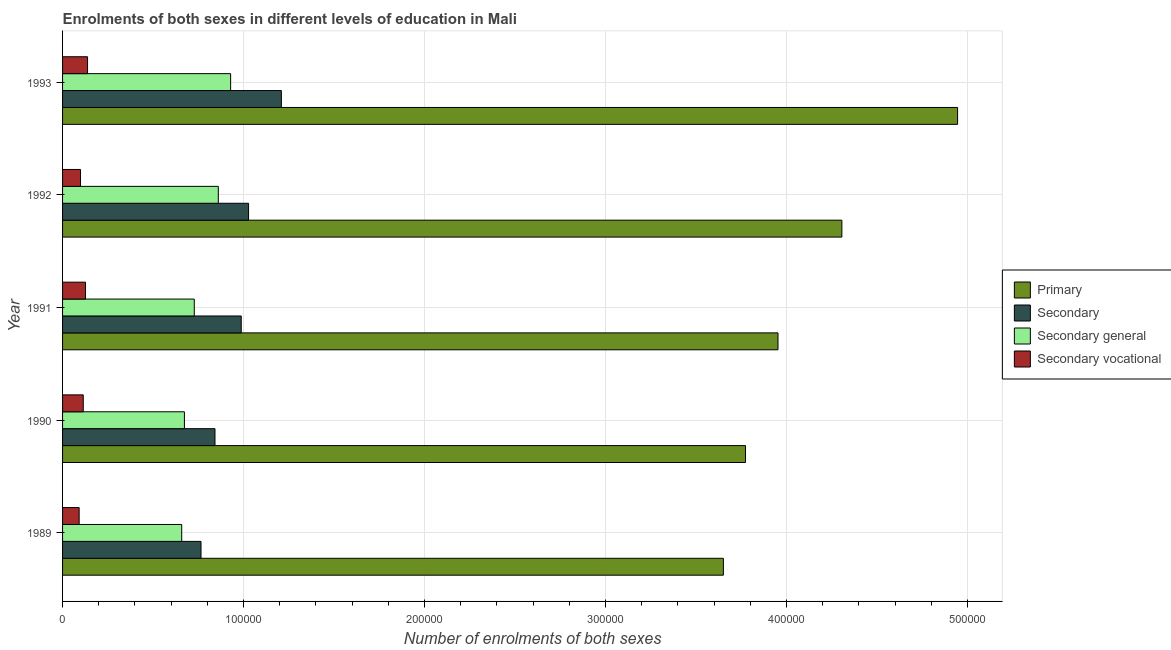How many different coloured bars are there?
Offer a terse response. 4. How many groups of bars are there?
Provide a short and direct response. 5. Are the number of bars per tick equal to the number of legend labels?
Your answer should be compact. Yes. How many bars are there on the 4th tick from the top?
Offer a terse response. 4. How many bars are there on the 4th tick from the bottom?
Make the answer very short. 4. In how many cases, is the number of bars for a given year not equal to the number of legend labels?
Provide a short and direct response. 0. What is the number of enrolments in primary education in 1992?
Your answer should be very brief. 4.31e+05. Across all years, what is the maximum number of enrolments in secondary general education?
Your response must be concise. 9.29e+04. Across all years, what is the minimum number of enrolments in secondary vocational education?
Your answer should be compact. 9164. In which year was the number of enrolments in primary education minimum?
Your answer should be very brief. 1989. What is the total number of enrolments in secondary vocational education in the graph?
Your answer should be very brief. 5.70e+04. What is the difference between the number of enrolments in secondary vocational education in 1989 and that in 1992?
Your answer should be very brief. -751. What is the difference between the number of enrolments in primary education in 1991 and the number of enrolments in secondary vocational education in 1993?
Give a very brief answer. 3.82e+05. What is the average number of enrolments in secondary education per year?
Keep it short and to the point. 9.66e+04. In the year 1989, what is the difference between the number of enrolments in primary education and number of enrolments in secondary education?
Offer a very short reply. 2.89e+05. What is the ratio of the number of enrolments in secondary education in 1992 to that in 1993?
Your answer should be very brief. 0.85. What is the difference between the highest and the second highest number of enrolments in secondary general education?
Your response must be concise. 6801. What is the difference between the highest and the lowest number of enrolments in primary education?
Your answer should be compact. 1.29e+05. In how many years, is the number of enrolments in primary education greater than the average number of enrolments in primary education taken over all years?
Offer a very short reply. 2. Is it the case that in every year, the sum of the number of enrolments in secondary vocational education and number of enrolments in secondary general education is greater than the sum of number of enrolments in primary education and number of enrolments in secondary education?
Give a very brief answer. No. What does the 3rd bar from the top in 1989 represents?
Provide a succinct answer. Secondary. What does the 1st bar from the bottom in 1991 represents?
Ensure brevity in your answer.  Primary. Is it the case that in every year, the sum of the number of enrolments in primary education and number of enrolments in secondary education is greater than the number of enrolments in secondary general education?
Provide a short and direct response. Yes. How many bars are there?
Provide a short and direct response. 20. How many years are there in the graph?
Offer a very short reply. 5. Are the values on the major ticks of X-axis written in scientific E-notation?
Offer a terse response. No. Does the graph contain any zero values?
Your answer should be very brief. No. Does the graph contain grids?
Your answer should be very brief. Yes. Where does the legend appear in the graph?
Your answer should be compact. Center right. How many legend labels are there?
Give a very brief answer. 4. What is the title of the graph?
Provide a short and direct response. Enrolments of both sexes in different levels of education in Mali. Does "Overall level" appear as one of the legend labels in the graph?
Provide a short and direct response. No. What is the label or title of the X-axis?
Keep it short and to the point. Number of enrolments of both sexes. What is the label or title of the Y-axis?
Ensure brevity in your answer.  Year. What is the Number of enrolments of both sexes in Primary in 1989?
Provide a short and direct response. 3.65e+05. What is the Number of enrolments of both sexes in Secondary in 1989?
Give a very brief answer. 7.65e+04. What is the Number of enrolments of both sexes of Secondary general in 1989?
Give a very brief answer. 6.58e+04. What is the Number of enrolments of both sexes of Secondary vocational in 1989?
Ensure brevity in your answer.  9164. What is the Number of enrolments of both sexes of Primary in 1990?
Make the answer very short. 3.77e+05. What is the Number of enrolments of both sexes of Secondary in 1990?
Your answer should be very brief. 8.42e+04. What is the Number of enrolments of both sexes of Secondary general in 1990?
Provide a succinct answer. 6.73e+04. What is the Number of enrolments of both sexes in Secondary vocational in 1990?
Ensure brevity in your answer.  1.14e+04. What is the Number of enrolments of both sexes of Primary in 1991?
Offer a terse response. 3.95e+05. What is the Number of enrolments of both sexes in Secondary in 1991?
Provide a succinct answer. 9.87e+04. What is the Number of enrolments of both sexes of Secondary general in 1991?
Provide a short and direct response. 7.28e+04. What is the Number of enrolments of both sexes in Secondary vocational in 1991?
Offer a very short reply. 1.27e+04. What is the Number of enrolments of both sexes in Primary in 1992?
Give a very brief answer. 4.31e+05. What is the Number of enrolments of both sexes in Secondary in 1992?
Provide a short and direct response. 1.03e+05. What is the Number of enrolments of both sexes of Secondary general in 1992?
Your response must be concise. 8.61e+04. What is the Number of enrolments of both sexes in Secondary vocational in 1992?
Offer a terse response. 9915. What is the Number of enrolments of both sexes of Primary in 1993?
Give a very brief answer. 4.95e+05. What is the Number of enrolments of both sexes of Secondary in 1993?
Your answer should be very brief. 1.21e+05. What is the Number of enrolments of both sexes in Secondary general in 1993?
Offer a very short reply. 9.29e+04. What is the Number of enrolments of both sexes in Secondary vocational in 1993?
Your response must be concise. 1.38e+04. Across all years, what is the maximum Number of enrolments of both sexes of Primary?
Your response must be concise. 4.95e+05. Across all years, what is the maximum Number of enrolments of both sexes of Secondary?
Offer a very short reply. 1.21e+05. Across all years, what is the maximum Number of enrolments of both sexes of Secondary general?
Provide a short and direct response. 9.29e+04. Across all years, what is the maximum Number of enrolments of both sexes in Secondary vocational?
Make the answer very short. 1.38e+04. Across all years, what is the minimum Number of enrolments of both sexes in Primary?
Provide a succinct answer. 3.65e+05. Across all years, what is the minimum Number of enrolments of both sexes of Secondary?
Your answer should be very brief. 7.65e+04. Across all years, what is the minimum Number of enrolments of both sexes in Secondary general?
Provide a short and direct response. 6.58e+04. Across all years, what is the minimum Number of enrolments of both sexes in Secondary vocational?
Provide a succinct answer. 9164. What is the total Number of enrolments of both sexes in Primary in the graph?
Provide a short and direct response. 2.06e+06. What is the total Number of enrolments of both sexes of Secondary in the graph?
Make the answer very short. 4.83e+05. What is the total Number of enrolments of both sexes in Secondary general in the graph?
Provide a short and direct response. 3.85e+05. What is the total Number of enrolments of both sexes in Secondary vocational in the graph?
Keep it short and to the point. 5.70e+04. What is the difference between the Number of enrolments of both sexes in Primary in 1989 and that in 1990?
Ensure brevity in your answer.  -1.22e+04. What is the difference between the Number of enrolments of both sexes of Secondary in 1989 and that in 1990?
Provide a short and direct response. -7719. What is the difference between the Number of enrolments of both sexes of Secondary general in 1989 and that in 1990?
Ensure brevity in your answer.  -1505. What is the difference between the Number of enrolments of both sexes in Secondary vocational in 1989 and that in 1990?
Provide a short and direct response. -2268. What is the difference between the Number of enrolments of both sexes of Primary in 1989 and that in 1991?
Provide a succinct answer. -3.02e+04. What is the difference between the Number of enrolments of both sexes of Secondary in 1989 and that in 1991?
Keep it short and to the point. -2.22e+04. What is the difference between the Number of enrolments of both sexes of Secondary general in 1989 and that in 1991?
Offer a very short reply. -6956. What is the difference between the Number of enrolments of both sexes in Secondary vocational in 1989 and that in 1991?
Keep it short and to the point. -3508. What is the difference between the Number of enrolments of both sexes in Primary in 1989 and that in 1992?
Provide a succinct answer. -6.55e+04. What is the difference between the Number of enrolments of both sexes of Secondary in 1989 and that in 1992?
Provide a short and direct response. -2.63e+04. What is the difference between the Number of enrolments of both sexes in Secondary general in 1989 and that in 1992?
Provide a short and direct response. -2.02e+04. What is the difference between the Number of enrolments of both sexes in Secondary vocational in 1989 and that in 1992?
Your answer should be very brief. -751. What is the difference between the Number of enrolments of both sexes of Primary in 1989 and that in 1993?
Offer a very short reply. -1.29e+05. What is the difference between the Number of enrolments of both sexes of Secondary in 1989 and that in 1993?
Give a very brief answer. -4.44e+04. What is the difference between the Number of enrolments of both sexes of Secondary general in 1989 and that in 1993?
Make the answer very short. -2.70e+04. What is the difference between the Number of enrolments of both sexes in Secondary vocational in 1989 and that in 1993?
Your answer should be compact. -4643. What is the difference between the Number of enrolments of both sexes in Primary in 1990 and that in 1991?
Your answer should be very brief. -1.80e+04. What is the difference between the Number of enrolments of both sexes of Secondary in 1990 and that in 1991?
Provide a succinct answer. -1.45e+04. What is the difference between the Number of enrolments of both sexes of Secondary general in 1990 and that in 1991?
Offer a very short reply. -5451. What is the difference between the Number of enrolments of both sexes of Secondary vocational in 1990 and that in 1991?
Your response must be concise. -1240. What is the difference between the Number of enrolments of both sexes in Primary in 1990 and that in 1992?
Keep it short and to the point. -5.33e+04. What is the difference between the Number of enrolments of both sexes of Secondary in 1990 and that in 1992?
Offer a very short reply. -1.86e+04. What is the difference between the Number of enrolments of both sexes of Secondary general in 1990 and that in 1992?
Keep it short and to the point. -1.87e+04. What is the difference between the Number of enrolments of both sexes of Secondary vocational in 1990 and that in 1992?
Ensure brevity in your answer.  1517. What is the difference between the Number of enrolments of both sexes in Primary in 1990 and that in 1993?
Make the answer very short. -1.17e+05. What is the difference between the Number of enrolments of both sexes of Secondary in 1990 and that in 1993?
Ensure brevity in your answer.  -3.67e+04. What is the difference between the Number of enrolments of both sexes of Secondary general in 1990 and that in 1993?
Your answer should be compact. -2.55e+04. What is the difference between the Number of enrolments of both sexes in Secondary vocational in 1990 and that in 1993?
Your answer should be very brief. -2375. What is the difference between the Number of enrolments of both sexes of Primary in 1991 and that in 1992?
Your answer should be compact. -3.53e+04. What is the difference between the Number of enrolments of both sexes in Secondary in 1991 and that in 1992?
Provide a short and direct response. -4044. What is the difference between the Number of enrolments of both sexes in Secondary general in 1991 and that in 1992?
Give a very brief answer. -1.33e+04. What is the difference between the Number of enrolments of both sexes of Secondary vocational in 1991 and that in 1992?
Your response must be concise. 2757. What is the difference between the Number of enrolments of both sexes in Primary in 1991 and that in 1993?
Keep it short and to the point. -9.92e+04. What is the difference between the Number of enrolments of both sexes in Secondary in 1991 and that in 1993?
Provide a short and direct response. -2.22e+04. What is the difference between the Number of enrolments of both sexes of Secondary general in 1991 and that in 1993?
Your response must be concise. -2.01e+04. What is the difference between the Number of enrolments of both sexes of Secondary vocational in 1991 and that in 1993?
Provide a succinct answer. -1135. What is the difference between the Number of enrolments of both sexes in Primary in 1992 and that in 1993?
Offer a very short reply. -6.39e+04. What is the difference between the Number of enrolments of both sexes in Secondary in 1992 and that in 1993?
Your answer should be compact. -1.81e+04. What is the difference between the Number of enrolments of both sexes in Secondary general in 1992 and that in 1993?
Keep it short and to the point. -6801. What is the difference between the Number of enrolments of both sexes of Secondary vocational in 1992 and that in 1993?
Your response must be concise. -3892. What is the difference between the Number of enrolments of both sexes in Primary in 1989 and the Number of enrolments of both sexes in Secondary in 1990?
Your answer should be compact. 2.81e+05. What is the difference between the Number of enrolments of both sexes in Primary in 1989 and the Number of enrolments of both sexes in Secondary general in 1990?
Provide a short and direct response. 2.98e+05. What is the difference between the Number of enrolments of both sexes in Primary in 1989 and the Number of enrolments of both sexes in Secondary vocational in 1990?
Give a very brief answer. 3.54e+05. What is the difference between the Number of enrolments of both sexes of Secondary in 1989 and the Number of enrolments of both sexes of Secondary general in 1990?
Provide a succinct answer. 9164. What is the difference between the Number of enrolments of both sexes in Secondary in 1989 and the Number of enrolments of both sexes in Secondary vocational in 1990?
Give a very brief answer. 6.51e+04. What is the difference between the Number of enrolments of both sexes in Secondary general in 1989 and the Number of enrolments of both sexes in Secondary vocational in 1990?
Your response must be concise. 5.44e+04. What is the difference between the Number of enrolments of both sexes in Primary in 1989 and the Number of enrolments of both sexes in Secondary in 1991?
Offer a terse response. 2.66e+05. What is the difference between the Number of enrolments of both sexes of Primary in 1989 and the Number of enrolments of both sexes of Secondary general in 1991?
Your response must be concise. 2.92e+05. What is the difference between the Number of enrolments of both sexes in Primary in 1989 and the Number of enrolments of both sexes in Secondary vocational in 1991?
Ensure brevity in your answer.  3.52e+05. What is the difference between the Number of enrolments of both sexes of Secondary in 1989 and the Number of enrolments of both sexes of Secondary general in 1991?
Make the answer very short. 3713. What is the difference between the Number of enrolments of both sexes in Secondary in 1989 and the Number of enrolments of both sexes in Secondary vocational in 1991?
Your answer should be very brief. 6.38e+04. What is the difference between the Number of enrolments of both sexes of Secondary general in 1989 and the Number of enrolments of both sexes of Secondary vocational in 1991?
Ensure brevity in your answer.  5.32e+04. What is the difference between the Number of enrolments of both sexes of Primary in 1989 and the Number of enrolments of both sexes of Secondary in 1992?
Keep it short and to the point. 2.62e+05. What is the difference between the Number of enrolments of both sexes of Primary in 1989 and the Number of enrolments of both sexes of Secondary general in 1992?
Your answer should be very brief. 2.79e+05. What is the difference between the Number of enrolments of both sexes of Primary in 1989 and the Number of enrolments of both sexes of Secondary vocational in 1992?
Give a very brief answer. 3.55e+05. What is the difference between the Number of enrolments of both sexes of Secondary in 1989 and the Number of enrolments of both sexes of Secondary general in 1992?
Your response must be concise. -9564. What is the difference between the Number of enrolments of both sexes in Secondary in 1989 and the Number of enrolments of both sexes in Secondary vocational in 1992?
Offer a very short reply. 6.66e+04. What is the difference between the Number of enrolments of both sexes of Secondary general in 1989 and the Number of enrolments of both sexes of Secondary vocational in 1992?
Provide a short and direct response. 5.59e+04. What is the difference between the Number of enrolments of both sexes of Primary in 1989 and the Number of enrolments of both sexes of Secondary in 1993?
Provide a short and direct response. 2.44e+05. What is the difference between the Number of enrolments of both sexes of Primary in 1989 and the Number of enrolments of both sexes of Secondary general in 1993?
Your answer should be very brief. 2.72e+05. What is the difference between the Number of enrolments of both sexes in Primary in 1989 and the Number of enrolments of both sexes in Secondary vocational in 1993?
Ensure brevity in your answer.  3.51e+05. What is the difference between the Number of enrolments of both sexes in Secondary in 1989 and the Number of enrolments of both sexes in Secondary general in 1993?
Make the answer very short. -1.64e+04. What is the difference between the Number of enrolments of both sexes in Secondary in 1989 and the Number of enrolments of both sexes in Secondary vocational in 1993?
Ensure brevity in your answer.  6.27e+04. What is the difference between the Number of enrolments of both sexes of Secondary general in 1989 and the Number of enrolments of both sexes of Secondary vocational in 1993?
Keep it short and to the point. 5.20e+04. What is the difference between the Number of enrolments of both sexes of Primary in 1990 and the Number of enrolments of both sexes of Secondary in 1991?
Make the answer very short. 2.79e+05. What is the difference between the Number of enrolments of both sexes in Primary in 1990 and the Number of enrolments of both sexes in Secondary general in 1991?
Make the answer very short. 3.05e+05. What is the difference between the Number of enrolments of both sexes of Primary in 1990 and the Number of enrolments of both sexes of Secondary vocational in 1991?
Provide a short and direct response. 3.65e+05. What is the difference between the Number of enrolments of both sexes of Secondary in 1990 and the Number of enrolments of both sexes of Secondary general in 1991?
Make the answer very short. 1.14e+04. What is the difference between the Number of enrolments of both sexes of Secondary in 1990 and the Number of enrolments of both sexes of Secondary vocational in 1991?
Ensure brevity in your answer.  7.15e+04. What is the difference between the Number of enrolments of both sexes in Secondary general in 1990 and the Number of enrolments of both sexes in Secondary vocational in 1991?
Offer a very short reply. 5.47e+04. What is the difference between the Number of enrolments of both sexes of Primary in 1990 and the Number of enrolments of both sexes of Secondary in 1992?
Provide a succinct answer. 2.75e+05. What is the difference between the Number of enrolments of both sexes in Primary in 1990 and the Number of enrolments of both sexes in Secondary general in 1992?
Give a very brief answer. 2.91e+05. What is the difference between the Number of enrolments of both sexes of Primary in 1990 and the Number of enrolments of both sexes of Secondary vocational in 1992?
Your response must be concise. 3.67e+05. What is the difference between the Number of enrolments of both sexes in Secondary in 1990 and the Number of enrolments of both sexes in Secondary general in 1992?
Your answer should be compact. -1845. What is the difference between the Number of enrolments of both sexes in Secondary in 1990 and the Number of enrolments of both sexes in Secondary vocational in 1992?
Your response must be concise. 7.43e+04. What is the difference between the Number of enrolments of both sexes in Secondary general in 1990 and the Number of enrolments of both sexes in Secondary vocational in 1992?
Ensure brevity in your answer.  5.74e+04. What is the difference between the Number of enrolments of both sexes of Primary in 1990 and the Number of enrolments of both sexes of Secondary in 1993?
Offer a very short reply. 2.56e+05. What is the difference between the Number of enrolments of both sexes in Primary in 1990 and the Number of enrolments of both sexes in Secondary general in 1993?
Provide a succinct answer. 2.85e+05. What is the difference between the Number of enrolments of both sexes in Primary in 1990 and the Number of enrolments of both sexes in Secondary vocational in 1993?
Provide a succinct answer. 3.64e+05. What is the difference between the Number of enrolments of both sexes in Secondary in 1990 and the Number of enrolments of both sexes in Secondary general in 1993?
Make the answer very short. -8646. What is the difference between the Number of enrolments of both sexes of Secondary in 1990 and the Number of enrolments of both sexes of Secondary vocational in 1993?
Provide a succinct answer. 7.04e+04. What is the difference between the Number of enrolments of both sexes of Secondary general in 1990 and the Number of enrolments of both sexes of Secondary vocational in 1993?
Keep it short and to the point. 5.35e+04. What is the difference between the Number of enrolments of both sexes of Primary in 1991 and the Number of enrolments of both sexes of Secondary in 1992?
Make the answer very short. 2.93e+05. What is the difference between the Number of enrolments of both sexes of Primary in 1991 and the Number of enrolments of both sexes of Secondary general in 1992?
Your response must be concise. 3.09e+05. What is the difference between the Number of enrolments of both sexes in Primary in 1991 and the Number of enrolments of both sexes in Secondary vocational in 1992?
Your answer should be very brief. 3.85e+05. What is the difference between the Number of enrolments of both sexes in Secondary in 1991 and the Number of enrolments of both sexes in Secondary general in 1992?
Provide a short and direct response. 1.27e+04. What is the difference between the Number of enrolments of both sexes of Secondary in 1991 and the Number of enrolments of both sexes of Secondary vocational in 1992?
Keep it short and to the point. 8.88e+04. What is the difference between the Number of enrolments of both sexes of Secondary general in 1991 and the Number of enrolments of both sexes of Secondary vocational in 1992?
Make the answer very short. 6.29e+04. What is the difference between the Number of enrolments of both sexes of Primary in 1991 and the Number of enrolments of both sexes of Secondary in 1993?
Your answer should be compact. 2.74e+05. What is the difference between the Number of enrolments of both sexes in Primary in 1991 and the Number of enrolments of both sexes in Secondary general in 1993?
Offer a terse response. 3.02e+05. What is the difference between the Number of enrolments of both sexes in Primary in 1991 and the Number of enrolments of both sexes in Secondary vocational in 1993?
Provide a succinct answer. 3.82e+05. What is the difference between the Number of enrolments of both sexes of Secondary in 1991 and the Number of enrolments of both sexes of Secondary general in 1993?
Provide a succinct answer. 5871. What is the difference between the Number of enrolments of both sexes in Secondary in 1991 and the Number of enrolments of both sexes in Secondary vocational in 1993?
Offer a very short reply. 8.49e+04. What is the difference between the Number of enrolments of both sexes of Secondary general in 1991 and the Number of enrolments of both sexes of Secondary vocational in 1993?
Provide a short and direct response. 5.90e+04. What is the difference between the Number of enrolments of both sexes of Primary in 1992 and the Number of enrolments of both sexes of Secondary in 1993?
Offer a very short reply. 3.10e+05. What is the difference between the Number of enrolments of both sexes of Primary in 1992 and the Number of enrolments of both sexes of Secondary general in 1993?
Provide a short and direct response. 3.38e+05. What is the difference between the Number of enrolments of both sexes of Primary in 1992 and the Number of enrolments of both sexes of Secondary vocational in 1993?
Provide a short and direct response. 4.17e+05. What is the difference between the Number of enrolments of both sexes in Secondary in 1992 and the Number of enrolments of both sexes in Secondary general in 1993?
Provide a short and direct response. 9915. What is the difference between the Number of enrolments of both sexes of Secondary in 1992 and the Number of enrolments of both sexes of Secondary vocational in 1993?
Provide a succinct answer. 8.90e+04. What is the difference between the Number of enrolments of both sexes of Secondary general in 1992 and the Number of enrolments of both sexes of Secondary vocational in 1993?
Make the answer very short. 7.23e+04. What is the average Number of enrolments of both sexes in Primary per year?
Give a very brief answer. 4.13e+05. What is the average Number of enrolments of both sexes in Secondary per year?
Give a very brief answer. 9.66e+04. What is the average Number of enrolments of both sexes of Secondary general per year?
Your answer should be very brief. 7.70e+04. What is the average Number of enrolments of both sexes of Secondary vocational per year?
Provide a succinct answer. 1.14e+04. In the year 1989, what is the difference between the Number of enrolments of both sexes of Primary and Number of enrolments of both sexes of Secondary?
Make the answer very short. 2.89e+05. In the year 1989, what is the difference between the Number of enrolments of both sexes in Primary and Number of enrolments of both sexes in Secondary general?
Ensure brevity in your answer.  2.99e+05. In the year 1989, what is the difference between the Number of enrolments of both sexes of Primary and Number of enrolments of both sexes of Secondary vocational?
Provide a succinct answer. 3.56e+05. In the year 1989, what is the difference between the Number of enrolments of both sexes of Secondary and Number of enrolments of both sexes of Secondary general?
Provide a short and direct response. 1.07e+04. In the year 1989, what is the difference between the Number of enrolments of both sexes of Secondary and Number of enrolments of both sexes of Secondary vocational?
Your answer should be compact. 6.73e+04. In the year 1989, what is the difference between the Number of enrolments of both sexes of Secondary general and Number of enrolments of both sexes of Secondary vocational?
Your answer should be very brief. 5.67e+04. In the year 1990, what is the difference between the Number of enrolments of both sexes in Primary and Number of enrolments of both sexes in Secondary?
Your response must be concise. 2.93e+05. In the year 1990, what is the difference between the Number of enrolments of both sexes of Primary and Number of enrolments of both sexes of Secondary general?
Your response must be concise. 3.10e+05. In the year 1990, what is the difference between the Number of enrolments of both sexes of Primary and Number of enrolments of both sexes of Secondary vocational?
Make the answer very short. 3.66e+05. In the year 1990, what is the difference between the Number of enrolments of both sexes of Secondary and Number of enrolments of both sexes of Secondary general?
Offer a very short reply. 1.69e+04. In the year 1990, what is the difference between the Number of enrolments of both sexes of Secondary and Number of enrolments of both sexes of Secondary vocational?
Offer a very short reply. 7.28e+04. In the year 1990, what is the difference between the Number of enrolments of both sexes of Secondary general and Number of enrolments of both sexes of Secondary vocational?
Give a very brief answer. 5.59e+04. In the year 1991, what is the difference between the Number of enrolments of both sexes of Primary and Number of enrolments of both sexes of Secondary?
Your answer should be very brief. 2.97e+05. In the year 1991, what is the difference between the Number of enrolments of both sexes of Primary and Number of enrolments of both sexes of Secondary general?
Offer a terse response. 3.23e+05. In the year 1991, what is the difference between the Number of enrolments of both sexes in Primary and Number of enrolments of both sexes in Secondary vocational?
Make the answer very short. 3.83e+05. In the year 1991, what is the difference between the Number of enrolments of both sexes of Secondary and Number of enrolments of both sexes of Secondary general?
Offer a very short reply. 2.59e+04. In the year 1991, what is the difference between the Number of enrolments of both sexes of Secondary and Number of enrolments of both sexes of Secondary vocational?
Provide a succinct answer. 8.61e+04. In the year 1991, what is the difference between the Number of enrolments of both sexes of Secondary general and Number of enrolments of both sexes of Secondary vocational?
Ensure brevity in your answer.  6.01e+04. In the year 1992, what is the difference between the Number of enrolments of both sexes in Primary and Number of enrolments of both sexes in Secondary?
Your response must be concise. 3.28e+05. In the year 1992, what is the difference between the Number of enrolments of both sexes of Primary and Number of enrolments of both sexes of Secondary general?
Offer a very short reply. 3.45e+05. In the year 1992, what is the difference between the Number of enrolments of both sexes of Primary and Number of enrolments of both sexes of Secondary vocational?
Offer a very short reply. 4.21e+05. In the year 1992, what is the difference between the Number of enrolments of both sexes of Secondary and Number of enrolments of both sexes of Secondary general?
Ensure brevity in your answer.  1.67e+04. In the year 1992, what is the difference between the Number of enrolments of both sexes in Secondary and Number of enrolments of both sexes in Secondary vocational?
Offer a very short reply. 9.29e+04. In the year 1992, what is the difference between the Number of enrolments of both sexes of Secondary general and Number of enrolments of both sexes of Secondary vocational?
Offer a terse response. 7.62e+04. In the year 1993, what is the difference between the Number of enrolments of both sexes in Primary and Number of enrolments of both sexes in Secondary?
Provide a succinct answer. 3.74e+05. In the year 1993, what is the difference between the Number of enrolments of both sexes of Primary and Number of enrolments of both sexes of Secondary general?
Give a very brief answer. 4.02e+05. In the year 1993, what is the difference between the Number of enrolments of both sexes of Primary and Number of enrolments of both sexes of Secondary vocational?
Provide a short and direct response. 4.81e+05. In the year 1993, what is the difference between the Number of enrolments of both sexes of Secondary and Number of enrolments of both sexes of Secondary general?
Your answer should be very brief. 2.80e+04. In the year 1993, what is the difference between the Number of enrolments of both sexes of Secondary and Number of enrolments of both sexes of Secondary vocational?
Your answer should be very brief. 1.07e+05. In the year 1993, what is the difference between the Number of enrolments of both sexes in Secondary general and Number of enrolments of both sexes in Secondary vocational?
Offer a very short reply. 7.91e+04. What is the ratio of the Number of enrolments of both sexes in Primary in 1989 to that in 1990?
Your response must be concise. 0.97. What is the ratio of the Number of enrolments of both sexes in Secondary in 1989 to that in 1990?
Your response must be concise. 0.91. What is the ratio of the Number of enrolments of both sexes in Secondary general in 1989 to that in 1990?
Make the answer very short. 0.98. What is the ratio of the Number of enrolments of both sexes in Secondary vocational in 1989 to that in 1990?
Ensure brevity in your answer.  0.8. What is the ratio of the Number of enrolments of both sexes in Primary in 1989 to that in 1991?
Give a very brief answer. 0.92. What is the ratio of the Number of enrolments of both sexes of Secondary in 1989 to that in 1991?
Provide a succinct answer. 0.77. What is the ratio of the Number of enrolments of both sexes of Secondary general in 1989 to that in 1991?
Your answer should be compact. 0.9. What is the ratio of the Number of enrolments of both sexes of Secondary vocational in 1989 to that in 1991?
Offer a terse response. 0.72. What is the ratio of the Number of enrolments of both sexes in Primary in 1989 to that in 1992?
Ensure brevity in your answer.  0.85. What is the ratio of the Number of enrolments of both sexes of Secondary in 1989 to that in 1992?
Ensure brevity in your answer.  0.74. What is the ratio of the Number of enrolments of both sexes in Secondary general in 1989 to that in 1992?
Give a very brief answer. 0.76. What is the ratio of the Number of enrolments of both sexes of Secondary vocational in 1989 to that in 1992?
Make the answer very short. 0.92. What is the ratio of the Number of enrolments of both sexes in Primary in 1989 to that in 1993?
Your response must be concise. 0.74. What is the ratio of the Number of enrolments of both sexes in Secondary in 1989 to that in 1993?
Your response must be concise. 0.63. What is the ratio of the Number of enrolments of both sexes of Secondary general in 1989 to that in 1993?
Provide a short and direct response. 0.71. What is the ratio of the Number of enrolments of both sexes of Secondary vocational in 1989 to that in 1993?
Your answer should be compact. 0.66. What is the ratio of the Number of enrolments of both sexes in Primary in 1990 to that in 1991?
Provide a short and direct response. 0.95. What is the ratio of the Number of enrolments of both sexes in Secondary in 1990 to that in 1991?
Your answer should be compact. 0.85. What is the ratio of the Number of enrolments of both sexes of Secondary general in 1990 to that in 1991?
Your response must be concise. 0.93. What is the ratio of the Number of enrolments of both sexes in Secondary vocational in 1990 to that in 1991?
Your answer should be compact. 0.9. What is the ratio of the Number of enrolments of both sexes of Primary in 1990 to that in 1992?
Your answer should be compact. 0.88. What is the ratio of the Number of enrolments of both sexes of Secondary in 1990 to that in 1992?
Ensure brevity in your answer.  0.82. What is the ratio of the Number of enrolments of both sexes in Secondary general in 1990 to that in 1992?
Provide a short and direct response. 0.78. What is the ratio of the Number of enrolments of both sexes of Secondary vocational in 1990 to that in 1992?
Your response must be concise. 1.15. What is the ratio of the Number of enrolments of both sexes of Primary in 1990 to that in 1993?
Offer a terse response. 0.76. What is the ratio of the Number of enrolments of both sexes in Secondary in 1990 to that in 1993?
Provide a succinct answer. 0.7. What is the ratio of the Number of enrolments of both sexes in Secondary general in 1990 to that in 1993?
Your answer should be compact. 0.73. What is the ratio of the Number of enrolments of both sexes of Secondary vocational in 1990 to that in 1993?
Provide a succinct answer. 0.83. What is the ratio of the Number of enrolments of both sexes of Primary in 1991 to that in 1992?
Make the answer very short. 0.92. What is the ratio of the Number of enrolments of both sexes in Secondary in 1991 to that in 1992?
Your answer should be compact. 0.96. What is the ratio of the Number of enrolments of both sexes of Secondary general in 1991 to that in 1992?
Make the answer very short. 0.85. What is the ratio of the Number of enrolments of both sexes of Secondary vocational in 1991 to that in 1992?
Your answer should be very brief. 1.28. What is the ratio of the Number of enrolments of both sexes of Primary in 1991 to that in 1993?
Provide a succinct answer. 0.8. What is the ratio of the Number of enrolments of both sexes of Secondary in 1991 to that in 1993?
Your answer should be compact. 0.82. What is the ratio of the Number of enrolments of both sexes of Secondary general in 1991 to that in 1993?
Keep it short and to the point. 0.78. What is the ratio of the Number of enrolments of both sexes of Secondary vocational in 1991 to that in 1993?
Ensure brevity in your answer.  0.92. What is the ratio of the Number of enrolments of both sexes in Primary in 1992 to that in 1993?
Ensure brevity in your answer.  0.87. What is the ratio of the Number of enrolments of both sexes in Secondary in 1992 to that in 1993?
Keep it short and to the point. 0.85. What is the ratio of the Number of enrolments of both sexes of Secondary general in 1992 to that in 1993?
Provide a succinct answer. 0.93. What is the ratio of the Number of enrolments of both sexes in Secondary vocational in 1992 to that in 1993?
Ensure brevity in your answer.  0.72. What is the difference between the highest and the second highest Number of enrolments of both sexes in Primary?
Keep it short and to the point. 6.39e+04. What is the difference between the highest and the second highest Number of enrolments of both sexes of Secondary?
Your answer should be very brief. 1.81e+04. What is the difference between the highest and the second highest Number of enrolments of both sexes in Secondary general?
Your answer should be compact. 6801. What is the difference between the highest and the second highest Number of enrolments of both sexes in Secondary vocational?
Give a very brief answer. 1135. What is the difference between the highest and the lowest Number of enrolments of both sexes of Primary?
Your answer should be compact. 1.29e+05. What is the difference between the highest and the lowest Number of enrolments of both sexes of Secondary?
Offer a terse response. 4.44e+04. What is the difference between the highest and the lowest Number of enrolments of both sexes of Secondary general?
Your answer should be very brief. 2.70e+04. What is the difference between the highest and the lowest Number of enrolments of both sexes of Secondary vocational?
Your answer should be compact. 4643. 